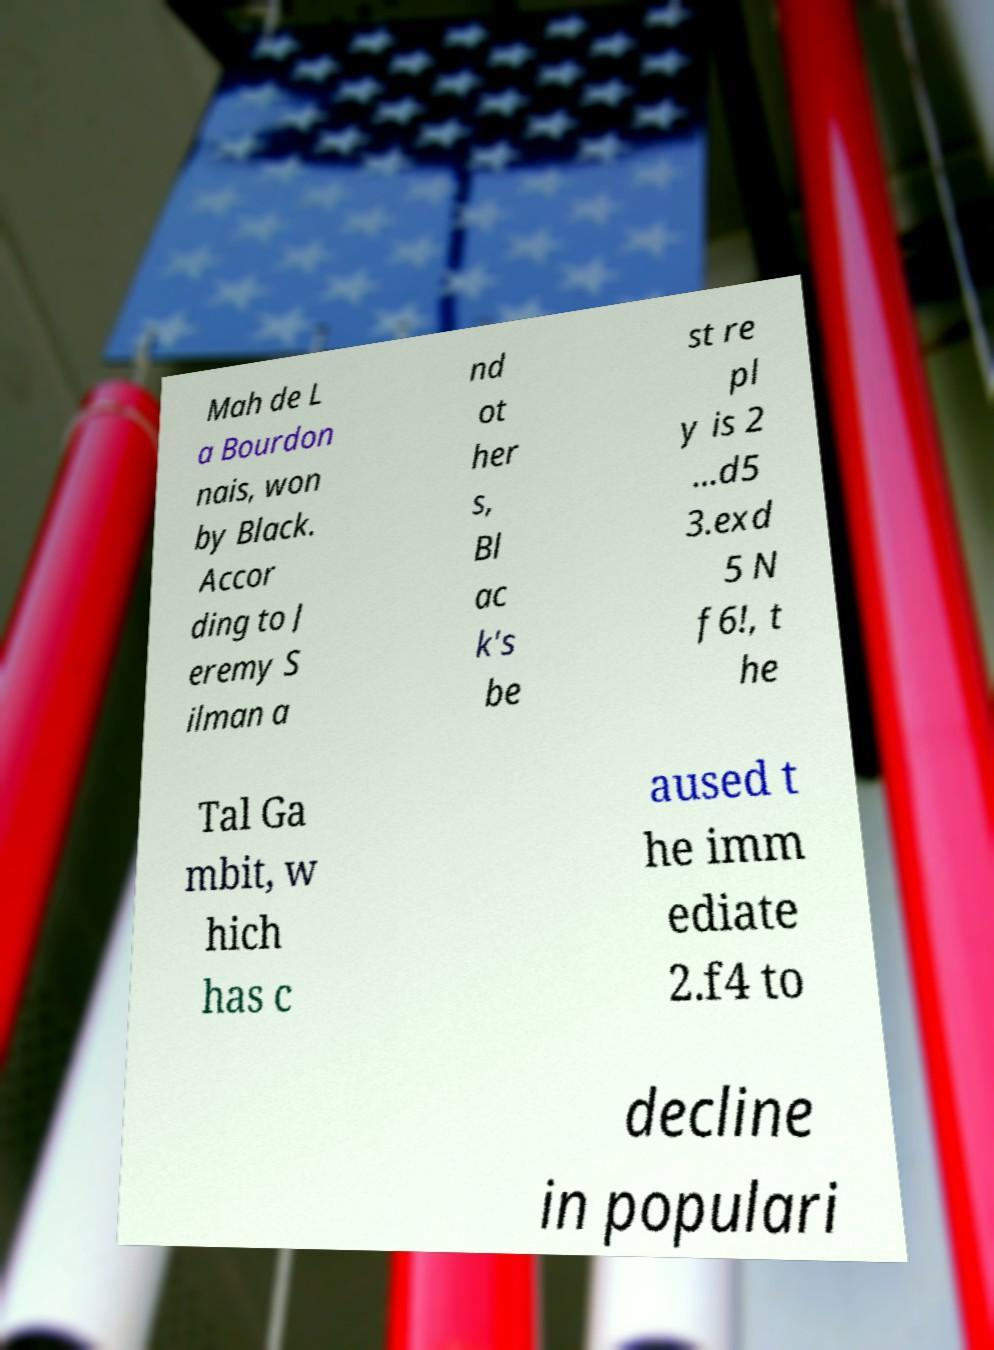For documentation purposes, I need the text within this image transcribed. Could you provide that? Mah de L a Bourdon nais, won by Black. Accor ding to J eremy S ilman a nd ot her s, Bl ac k's be st re pl y is 2 ...d5 3.exd 5 N f6!, t he Tal Ga mbit, w hich has c aused t he imm ediate 2.f4 to decline in populari 